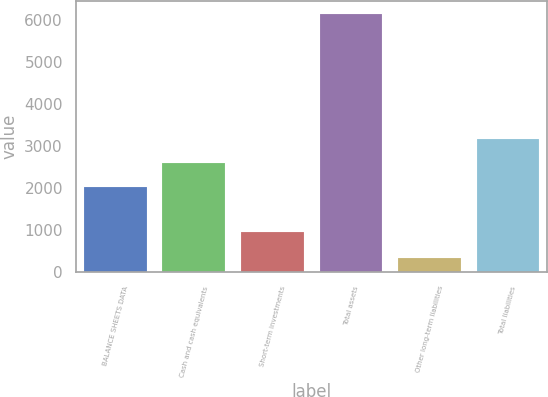<chart> <loc_0><loc_0><loc_500><loc_500><bar_chart><fcel>BALANCE SHEETS DATA<fcel>Cash and cash equivalents<fcel>Short-term investments<fcel>Total assets<fcel>Other long-term liabilities<fcel>Total liabilities<nl><fcel>2015<fcel>2596.4<fcel>953<fcel>6147<fcel>333<fcel>3177.8<nl></chart> 